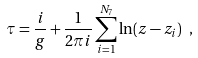<formula> <loc_0><loc_0><loc_500><loc_500>\tau = \frac { i } { g } + \frac { 1 } { 2 \pi i } \sum _ { i = 1 } ^ { N _ { 7 } } \ln ( z - z _ { i } ) \ ,</formula> 